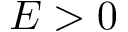<formula> <loc_0><loc_0><loc_500><loc_500>E > 0</formula> 